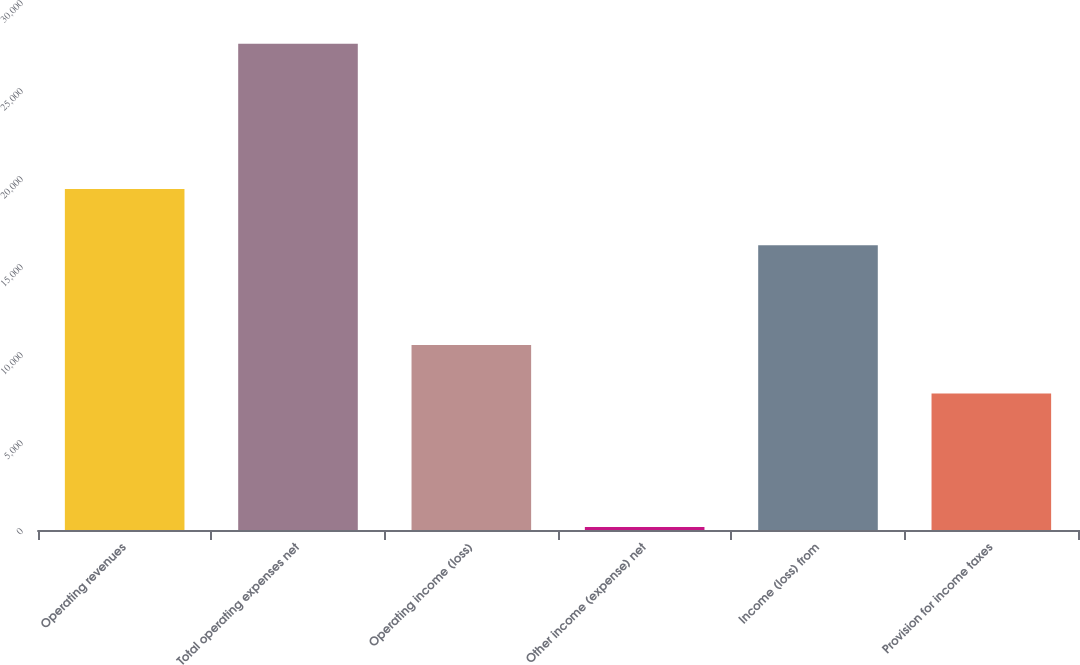Convert chart to OTSL. <chart><loc_0><loc_0><loc_500><loc_500><bar_chart><fcel>Operating revenues<fcel>Total operating expenses net<fcel>Operating income (loss)<fcel>Other income (expense) net<fcel>Income (loss) from<fcel>Provision for income taxes<nl><fcel>19377<fcel>27630<fcel>10505.2<fcel>168<fcel>16180<fcel>7759<nl></chart> 